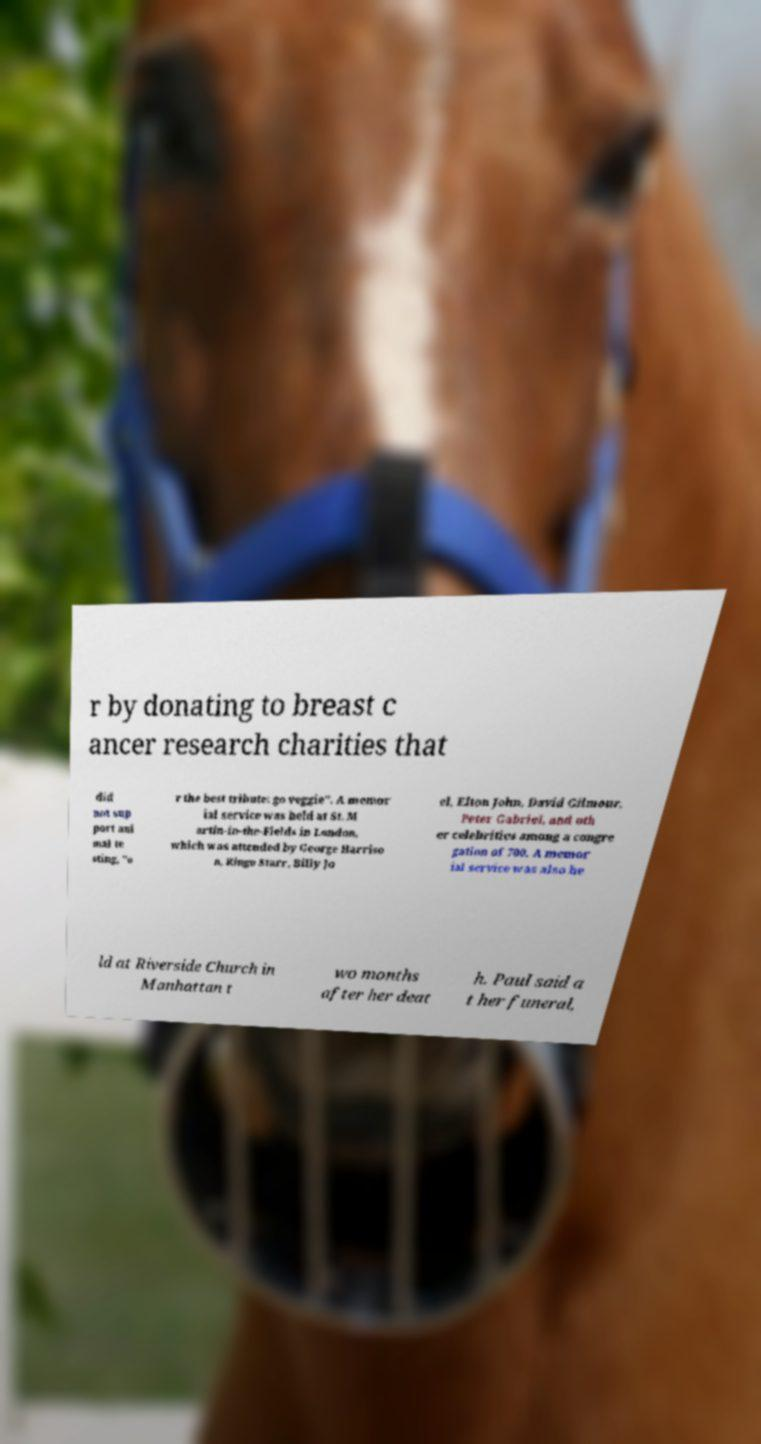For documentation purposes, I need the text within this image transcribed. Could you provide that? r by donating to breast c ancer research charities that did not sup port ani mal te sting, "o r the best tribute: go veggie". A memor ial service was held at St. M artin-in-the-Fields in London, which was attended by George Harriso n, Ringo Starr, Billy Jo el, Elton John, David Gilmour, Peter Gabriel, and oth er celebrities among a congre gation of 700. A memor ial service was also he ld at Riverside Church in Manhattan t wo months after her deat h. Paul said a t her funeral, 